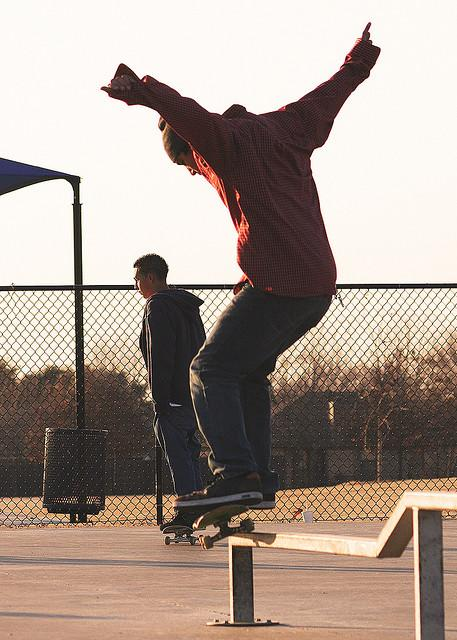What is the skater doing on the rail? grinding 